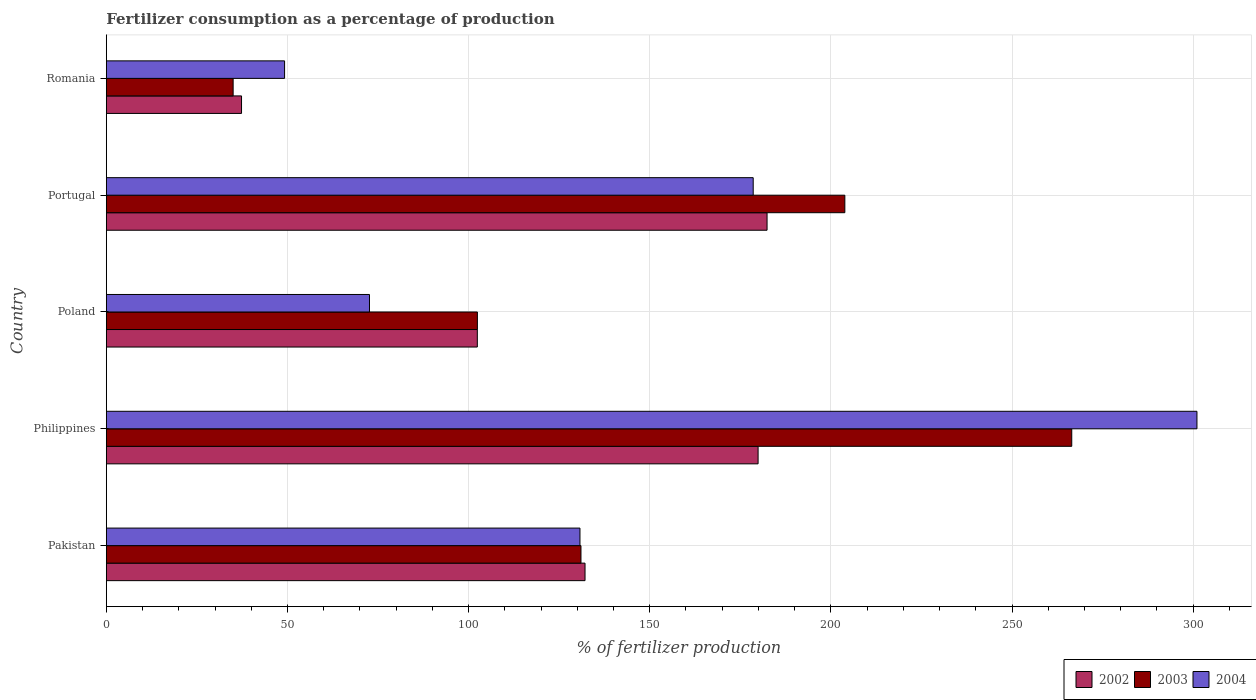How many different coloured bars are there?
Ensure brevity in your answer.  3. How many groups of bars are there?
Your answer should be very brief. 5. Are the number of bars per tick equal to the number of legend labels?
Your response must be concise. Yes. Are the number of bars on each tick of the Y-axis equal?
Your response must be concise. Yes. What is the percentage of fertilizers consumed in 2003 in Pakistan?
Offer a very short reply. 131.01. Across all countries, what is the maximum percentage of fertilizers consumed in 2004?
Your response must be concise. 301.04. Across all countries, what is the minimum percentage of fertilizers consumed in 2002?
Your response must be concise. 37.32. In which country was the percentage of fertilizers consumed in 2003 maximum?
Keep it short and to the point. Philippines. In which country was the percentage of fertilizers consumed in 2003 minimum?
Your answer should be very brief. Romania. What is the total percentage of fertilizers consumed in 2002 in the graph?
Offer a very short reply. 634.13. What is the difference between the percentage of fertilizers consumed in 2002 in Pakistan and that in Portugal?
Provide a succinct answer. -50.24. What is the difference between the percentage of fertilizers consumed in 2002 in Romania and the percentage of fertilizers consumed in 2004 in Portugal?
Make the answer very short. -141.23. What is the average percentage of fertilizers consumed in 2003 per country?
Provide a short and direct response. 147.75. What is the difference between the percentage of fertilizers consumed in 2003 and percentage of fertilizers consumed in 2004 in Philippines?
Make the answer very short. -34.56. What is the ratio of the percentage of fertilizers consumed in 2002 in Pakistan to that in Portugal?
Make the answer very short. 0.72. What is the difference between the highest and the second highest percentage of fertilizers consumed in 2002?
Your response must be concise. 2.48. What is the difference between the highest and the lowest percentage of fertilizers consumed in 2004?
Provide a short and direct response. 251.84. In how many countries, is the percentage of fertilizers consumed in 2003 greater than the average percentage of fertilizers consumed in 2003 taken over all countries?
Offer a terse response. 2. What does the 1st bar from the top in Philippines represents?
Keep it short and to the point. 2004. Is it the case that in every country, the sum of the percentage of fertilizers consumed in 2002 and percentage of fertilizers consumed in 2003 is greater than the percentage of fertilizers consumed in 2004?
Make the answer very short. Yes. How many bars are there?
Keep it short and to the point. 15. Are all the bars in the graph horizontal?
Give a very brief answer. Yes. What is the difference between two consecutive major ticks on the X-axis?
Ensure brevity in your answer.  50. Are the values on the major ticks of X-axis written in scientific E-notation?
Keep it short and to the point. No. Does the graph contain any zero values?
Provide a succinct answer. No. How many legend labels are there?
Your answer should be very brief. 3. What is the title of the graph?
Your response must be concise. Fertilizer consumption as a percentage of production. Does "1986" appear as one of the legend labels in the graph?
Offer a very short reply. No. What is the label or title of the X-axis?
Provide a short and direct response. % of fertilizer production. What is the % of fertilizer production of 2002 in Pakistan?
Give a very brief answer. 132.13. What is the % of fertilizer production in 2003 in Pakistan?
Make the answer very short. 131.01. What is the % of fertilizer production of 2004 in Pakistan?
Your response must be concise. 130.73. What is the % of fertilizer production of 2002 in Philippines?
Keep it short and to the point. 179.9. What is the % of fertilizer production of 2003 in Philippines?
Give a very brief answer. 266.48. What is the % of fertilizer production in 2004 in Philippines?
Make the answer very short. 301.04. What is the % of fertilizer production of 2002 in Poland?
Your answer should be very brief. 102.4. What is the % of fertilizer production of 2003 in Poland?
Offer a terse response. 102.42. What is the % of fertilizer production in 2004 in Poland?
Give a very brief answer. 72.64. What is the % of fertilizer production in 2002 in Portugal?
Offer a terse response. 182.38. What is the % of fertilizer production of 2003 in Portugal?
Your answer should be very brief. 203.85. What is the % of fertilizer production of 2004 in Portugal?
Keep it short and to the point. 178.55. What is the % of fertilizer production of 2002 in Romania?
Your answer should be very brief. 37.32. What is the % of fertilizer production of 2003 in Romania?
Give a very brief answer. 35. What is the % of fertilizer production of 2004 in Romania?
Offer a terse response. 49.2. Across all countries, what is the maximum % of fertilizer production in 2002?
Provide a succinct answer. 182.38. Across all countries, what is the maximum % of fertilizer production in 2003?
Provide a short and direct response. 266.48. Across all countries, what is the maximum % of fertilizer production in 2004?
Your answer should be very brief. 301.04. Across all countries, what is the minimum % of fertilizer production in 2002?
Your answer should be very brief. 37.32. Across all countries, what is the minimum % of fertilizer production of 2003?
Provide a succinct answer. 35. Across all countries, what is the minimum % of fertilizer production of 2004?
Provide a succinct answer. 49.2. What is the total % of fertilizer production of 2002 in the graph?
Make the answer very short. 634.13. What is the total % of fertilizer production in 2003 in the graph?
Provide a short and direct response. 738.76. What is the total % of fertilizer production in 2004 in the graph?
Offer a terse response. 732.16. What is the difference between the % of fertilizer production of 2002 in Pakistan and that in Philippines?
Provide a short and direct response. -47.77. What is the difference between the % of fertilizer production of 2003 in Pakistan and that in Philippines?
Provide a succinct answer. -135.47. What is the difference between the % of fertilizer production of 2004 in Pakistan and that in Philippines?
Ensure brevity in your answer.  -170.31. What is the difference between the % of fertilizer production in 2002 in Pakistan and that in Poland?
Offer a very short reply. 29.73. What is the difference between the % of fertilizer production of 2003 in Pakistan and that in Poland?
Provide a succinct answer. 28.59. What is the difference between the % of fertilizer production in 2004 in Pakistan and that in Poland?
Your answer should be very brief. 58.1. What is the difference between the % of fertilizer production in 2002 in Pakistan and that in Portugal?
Offer a very short reply. -50.24. What is the difference between the % of fertilizer production of 2003 in Pakistan and that in Portugal?
Provide a short and direct response. -72.84. What is the difference between the % of fertilizer production in 2004 in Pakistan and that in Portugal?
Offer a terse response. -47.82. What is the difference between the % of fertilizer production of 2002 in Pakistan and that in Romania?
Offer a very short reply. 94.81. What is the difference between the % of fertilizer production of 2003 in Pakistan and that in Romania?
Your answer should be compact. 96.01. What is the difference between the % of fertilizer production of 2004 in Pakistan and that in Romania?
Ensure brevity in your answer.  81.54. What is the difference between the % of fertilizer production in 2002 in Philippines and that in Poland?
Keep it short and to the point. 77.5. What is the difference between the % of fertilizer production of 2003 in Philippines and that in Poland?
Your answer should be compact. 164.06. What is the difference between the % of fertilizer production of 2004 in Philippines and that in Poland?
Provide a succinct answer. 228.4. What is the difference between the % of fertilizer production in 2002 in Philippines and that in Portugal?
Provide a short and direct response. -2.48. What is the difference between the % of fertilizer production in 2003 in Philippines and that in Portugal?
Your answer should be compact. 62.63. What is the difference between the % of fertilizer production in 2004 in Philippines and that in Portugal?
Your answer should be very brief. 122.49. What is the difference between the % of fertilizer production in 2002 in Philippines and that in Romania?
Provide a short and direct response. 142.58. What is the difference between the % of fertilizer production of 2003 in Philippines and that in Romania?
Ensure brevity in your answer.  231.48. What is the difference between the % of fertilizer production of 2004 in Philippines and that in Romania?
Ensure brevity in your answer.  251.84. What is the difference between the % of fertilizer production of 2002 in Poland and that in Portugal?
Your response must be concise. -79.97. What is the difference between the % of fertilizer production in 2003 in Poland and that in Portugal?
Give a very brief answer. -101.43. What is the difference between the % of fertilizer production in 2004 in Poland and that in Portugal?
Your response must be concise. -105.91. What is the difference between the % of fertilizer production in 2002 in Poland and that in Romania?
Your answer should be very brief. 65.08. What is the difference between the % of fertilizer production in 2003 in Poland and that in Romania?
Provide a succinct answer. 67.42. What is the difference between the % of fertilizer production in 2004 in Poland and that in Romania?
Give a very brief answer. 23.44. What is the difference between the % of fertilizer production of 2002 in Portugal and that in Romania?
Keep it short and to the point. 145.06. What is the difference between the % of fertilizer production of 2003 in Portugal and that in Romania?
Ensure brevity in your answer.  168.85. What is the difference between the % of fertilizer production in 2004 in Portugal and that in Romania?
Offer a very short reply. 129.35. What is the difference between the % of fertilizer production of 2002 in Pakistan and the % of fertilizer production of 2003 in Philippines?
Your answer should be compact. -134.34. What is the difference between the % of fertilizer production in 2002 in Pakistan and the % of fertilizer production in 2004 in Philippines?
Make the answer very short. -168.91. What is the difference between the % of fertilizer production in 2003 in Pakistan and the % of fertilizer production in 2004 in Philippines?
Make the answer very short. -170.03. What is the difference between the % of fertilizer production of 2002 in Pakistan and the % of fertilizer production of 2003 in Poland?
Your answer should be very brief. 29.71. What is the difference between the % of fertilizer production of 2002 in Pakistan and the % of fertilizer production of 2004 in Poland?
Offer a terse response. 59.5. What is the difference between the % of fertilizer production of 2003 in Pakistan and the % of fertilizer production of 2004 in Poland?
Your answer should be compact. 58.37. What is the difference between the % of fertilizer production in 2002 in Pakistan and the % of fertilizer production in 2003 in Portugal?
Your answer should be very brief. -71.71. What is the difference between the % of fertilizer production of 2002 in Pakistan and the % of fertilizer production of 2004 in Portugal?
Ensure brevity in your answer.  -46.42. What is the difference between the % of fertilizer production of 2003 in Pakistan and the % of fertilizer production of 2004 in Portugal?
Provide a succinct answer. -47.54. What is the difference between the % of fertilizer production of 2002 in Pakistan and the % of fertilizer production of 2003 in Romania?
Your answer should be very brief. 97.13. What is the difference between the % of fertilizer production of 2002 in Pakistan and the % of fertilizer production of 2004 in Romania?
Ensure brevity in your answer.  82.94. What is the difference between the % of fertilizer production in 2003 in Pakistan and the % of fertilizer production in 2004 in Romania?
Make the answer very short. 81.81. What is the difference between the % of fertilizer production in 2002 in Philippines and the % of fertilizer production in 2003 in Poland?
Your answer should be compact. 77.48. What is the difference between the % of fertilizer production of 2002 in Philippines and the % of fertilizer production of 2004 in Poland?
Ensure brevity in your answer.  107.26. What is the difference between the % of fertilizer production in 2003 in Philippines and the % of fertilizer production in 2004 in Poland?
Offer a terse response. 193.84. What is the difference between the % of fertilizer production of 2002 in Philippines and the % of fertilizer production of 2003 in Portugal?
Your response must be concise. -23.95. What is the difference between the % of fertilizer production in 2002 in Philippines and the % of fertilizer production in 2004 in Portugal?
Provide a short and direct response. 1.35. What is the difference between the % of fertilizer production in 2003 in Philippines and the % of fertilizer production in 2004 in Portugal?
Ensure brevity in your answer.  87.93. What is the difference between the % of fertilizer production of 2002 in Philippines and the % of fertilizer production of 2003 in Romania?
Your response must be concise. 144.9. What is the difference between the % of fertilizer production in 2002 in Philippines and the % of fertilizer production in 2004 in Romania?
Provide a succinct answer. 130.7. What is the difference between the % of fertilizer production of 2003 in Philippines and the % of fertilizer production of 2004 in Romania?
Give a very brief answer. 217.28. What is the difference between the % of fertilizer production of 2002 in Poland and the % of fertilizer production of 2003 in Portugal?
Your answer should be very brief. -101.45. What is the difference between the % of fertilizer production in 2002 in Poland and the % of fertilizer production in 2004 in Portugal?
Offer a very short reply. -76.15. What is the difference between the % of fertilizer production in 2003 in Poland and the % of fertilizer production in 2004 in Portugal?
Provide a short and direct response. -76.13. What is the difference between the % of fertilizer production of 2002 in Poland and the % of fertilizer production of 2003 in Romania?
Give a very brief answer. 67.4. What is the difference between the % of fertilizer production in 2002 in Poland and the % of fertilizer production in 2004 in Romania?
Provide a succinct answer. 53.2. What is the difference between the % of fertilizer production in 2003 in Poland and the % of fertilizer production in 2004 in Romania?
Give a very brief answer. 53.22. What is the difference between the % of fertilizer production in 2002 in Portugal and the % of fertilizer production in 2003 in Romania?
Offer a very short reply. 147.38. What is the difference between the % of fertilizer production of 2002 in Portugal and the % of fertilizer production of 2004 in Romania?
Ensure brevity in your answer.  133.18. What is the difference between the % of fertilizer production in 2003 in Portugal and the % of fertilizer production in 2004 in Romania?
Give a very brief answer. 154.65. What is the average % of fertilizer production of 2002 per country?
Offer a terse response. 126.83. What is the average % of fertilizer production in 2003 per country?
Provide a short and direct response. 147.75. What is the average % of fertilizer production in 2004 per country?
Your response must be concise. 146.43. What is the difference between the % of fertilizer production in 2002 and % of fertilizer production in 2003 in Pakistan?
Ensure brevity in your answer.  1.12. What is the difference between the % of fertilizer production in 2002 and % of fertilizer production in 2004 in Pakistan?
Your answer should be very brief. 1.4. What is the difference between the % of fertilizer production of 2003 and % of fertilizer production of 2004 in Pakistan?
Your answer should be compact. 0.28. What is the difference between the % of fertilizer production in 2002 and % of fertilizer production in 2003 in Philippines?
Your answer should be very brief. -86.58. What is the difference between the % of fertilizer production in 2002 and % of fertilizer production in 2004 in Philippines?
Keep it short and to the point. -121.14. What is the difference between the % of fertilizer production of 2003 and % of fertilizer production of 2004 in Philippines?
Provide a short and direct response. -34.56. What is the difference between the % of fertilizer production of 2002 and % of fertilizer production of 2003 in Poland?
Offer a terse response. -0.02. What is the difference between the % of fertilizer production of 2002 and % of fertilizer production of 2004 in Poland?
Your answer should be very brief. 29.77. What is the difference between the % of fertilizer production in 2003 and % of fertilizer production in 2004 in Poland?
Offer a very short reply. 29.78. What is the difference between the % of fertilizer production in 2002 and % of fertilizer production in 2003 in Portugal?
Your answer should be compact. -21.47. What is the difference between the % of fertilizer production in 2002 and % of fertilizer production in 2004 in Portugal?
Provide a succinct answer. 3.83. What is the difference between the % of fertilizer production of 2003 and % of fertilizer production of 2004 in Portugal?
Make the answer very short. 25.3. What is the difference between the % of fertilizer production in 2002 and % of fertilizer production in 2003 in Romania?
Offer a very short reply. 2.32. What is the difference between the % of fertilizer production of 2002 and % of fertilizer production of 2004 in Romania?
Keep it short and to the point. -11.88. What is the difference between the % of fertilizer production in 2003 and % of fertilizer production in 2004 in Romania?
Keep it short and to the point. -14.2. What is the ratio of the % of fertilizer production in 2002 in Pakistan to that in Philippines?
Keep it short and to the point. 0.73. What is the ratio of the % of fertilizer production of 2003 in Pakistan to that in Philippines?
Your answer should be very brief. 0.49. What is the ratio of the % of fertilizer production of 2004 in Pakistan to that in Philippines?
Your answer should be compact. 0.43. What is the ratio of the % of fertilizer production of 2002 in Pakistan to that in Poland?
Provide a succinct answer. 1.29. What is the ratio of the % of fertilizer production of 2003 in Pakistan to that in Poland?
Provide a succinct answer. 1.28. What is the ratio of the % of fertilizer production of 2004 in Pakistan to that in Poland?
Ensure brevity in your answer.  1.8. What is the ratio of the % of fertilizer production in 2002 in Pakistan to that in Portugal?
Provide a succinct answer. 0.72. What is the ratio of the % of fertilizer production in 2003 in Pakistan to that in Portugal?
Make the answer very short. 0.64. What is the ratio of the % of fertilizer production of 2004 in Pakistan to that in Portugal?
Make the answer very short. 0.73. What is the ratio of the % of fertilizer production of 2002 in Pakistan to that in Romania?
Give a very brief answer. 3.54. What is the ratio of the % of fertilizer production in 2003 in Pakistan to that in Romania?
Your answer should be compact. 3.74. What is the ratio of the % of fertilizer production of 2004 in Pakistan to that in Romania?
Your answer should be compact. 2.66. What is the ratio of the % of fertilizer production in 2002 in Philippines to that in Poland?
Offer a terse response. 1.76. What is the ratio of the % of fertilizer production of 2003 in Philippines to that in Poland?
Keep it short and to the point. 2.6. What is the ratio of the % of fertilizer production in 2004 in Philippines to that in Poland?
Offer a very short reply. 4.14. What is the ratio of the % of fertilizer production in 2002 in Philippines to that in Portugal?
Offer a terse response. 0.99. What is the ratio of the % of fertilizer production of 2003 in Philippines to that in Portugal?
Offer a very short reply. 1.31. What is the ratio of the % of fertilizer production in 2004 in Philippines to that in Portugal?
Make the answer very short. 1.69. What is the ratio of the % of fertilizer production in 2002 in Philippines to that in Romania?
Make the answer very short. 4.82. What is the ratio of the % of fertilizer production of 2003 in Philippines to that in Romania?
Your answer should be compact. 7.61. What is the ratio of the % of fertilizer production in 2004 in Philippines to that in Romania?
Give a very brief answer. 6.12. What is the ratio of the % of fertilizer production in 2002 in Poland to that in Portugal?
Your answer should be compact. 0.56. What is the ratio of the % of fertilizer production in 2003 in Poland to that in Portugal?
Offer a terse response. 0.5. What is the ratio of the % of fertilizer production in 2004 in Poland to that in Portugal?
Give a very brief answer. 0.41. What is the ratio of the % of fertilizer production of 2002 in Poland to that in Romania?
Provide a succinct answer. 2.74. What is the ratio of the % of fertilizer production of 2003 in Poland to that in Romania?
Offer a terse response. 2.93. What is the ratio of the % of fertilizer production in 2004 in Poland to that in Romania?
Offer a very short reply. 1.48. What is the ratio of the % of fertilizer production of 2002 in Portugal to that in Romania?
Provide a succinct answer. 4.89. What is the ratio of the % of fertilizer production of 2003 in Portugal to that in Romania?
Offer a very short reply. 5.82. What is the ratio of the % of fertilizer production of 2004 in Portugal to that in Romania?
Offer a terse response. 3.63. What is the difference between the highest and the second highest % of fertilizer production in 2002?
Your answer should be compact. 2.48. What is the difference between the highest and the second highest % of fertilizer production of 2003?
Offer a very short reply. 62.63. What is the difference between the highest and the second highest % of fertilizer production in 2004?
Your response must be concise. 122.49. What is the difference between the highest and the lowest % of fertilizer production of 2002?
Provide a succinct answer. 145.06. What is the difference between the highest and the lowest % of fertilizer production of 2003?
Provide a succinct answer. 231.48. What is the difference between the highest and the lowest % of fertilizer production of 2004?
Ensure brevity in your answer.  251.84. 